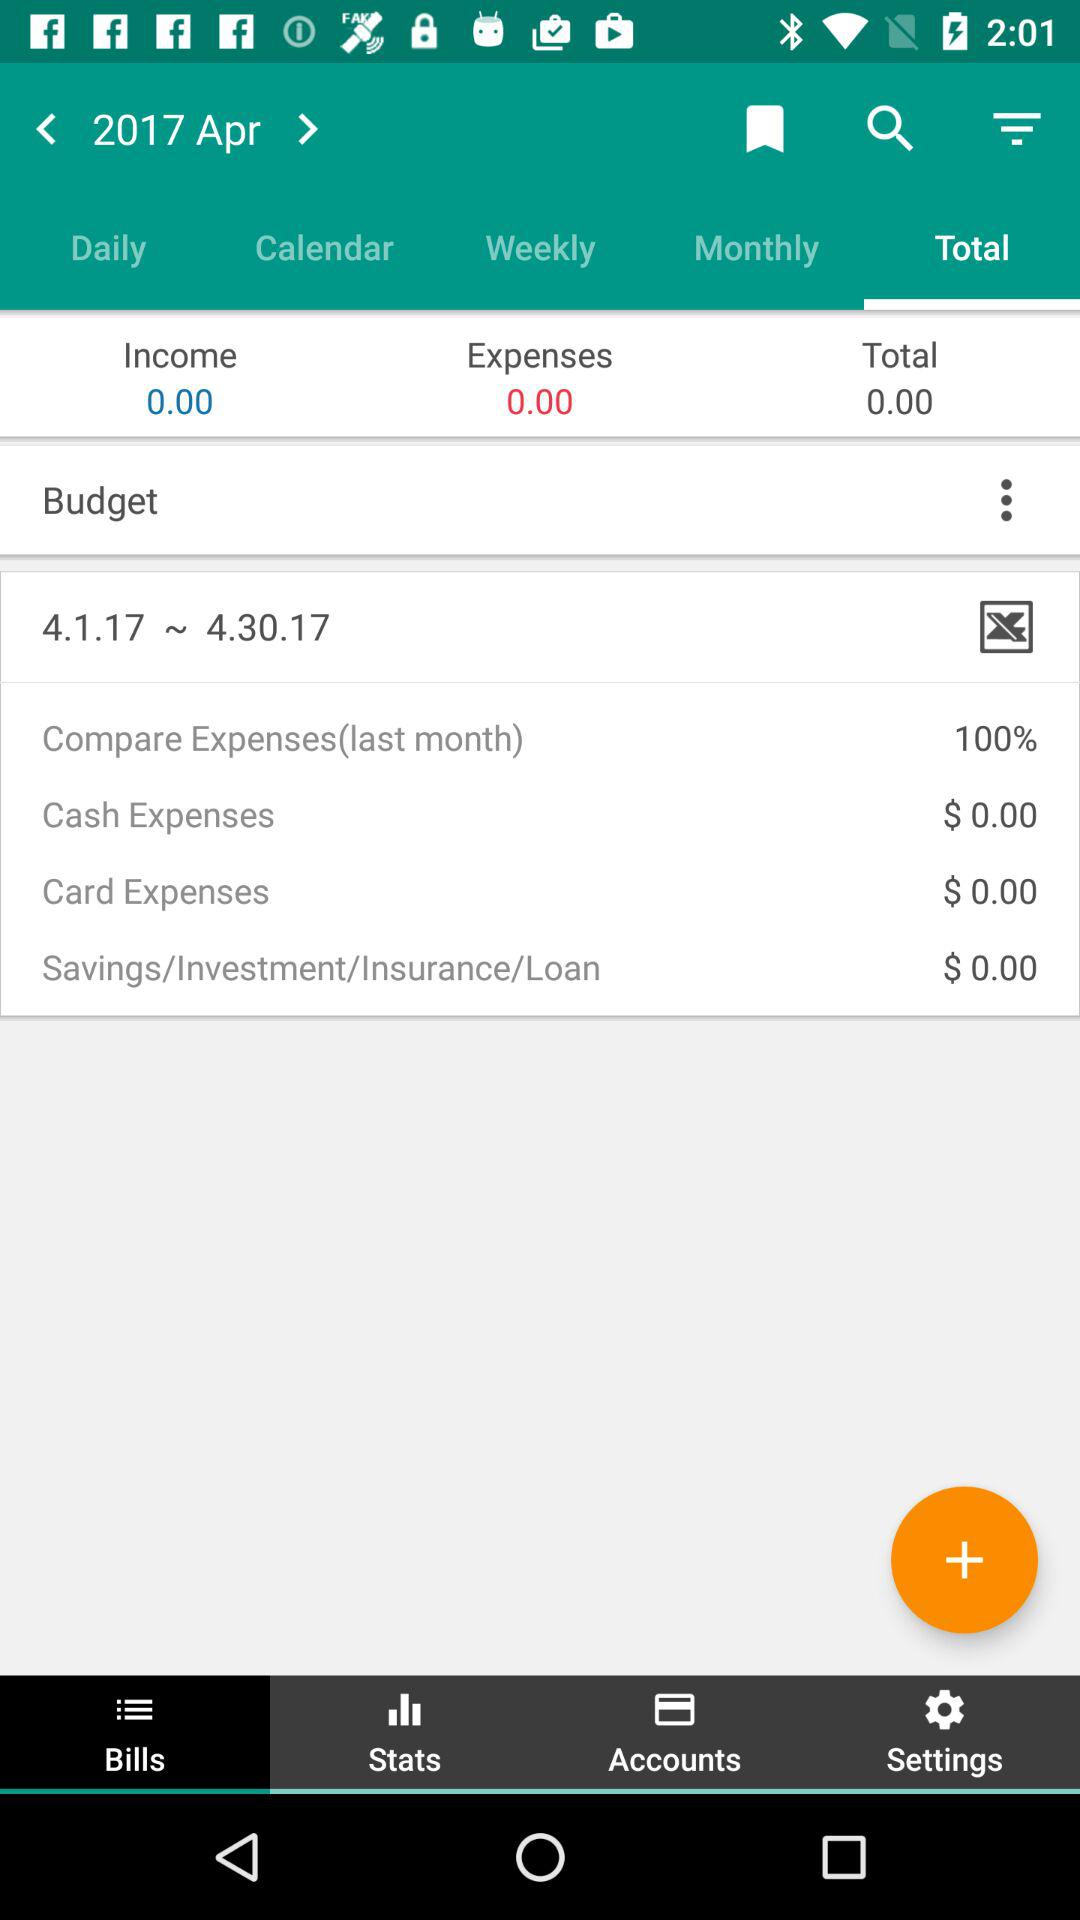What is the date range for the budget? The date range for the budget is from April 1, 2017 to April 30, 2017. 